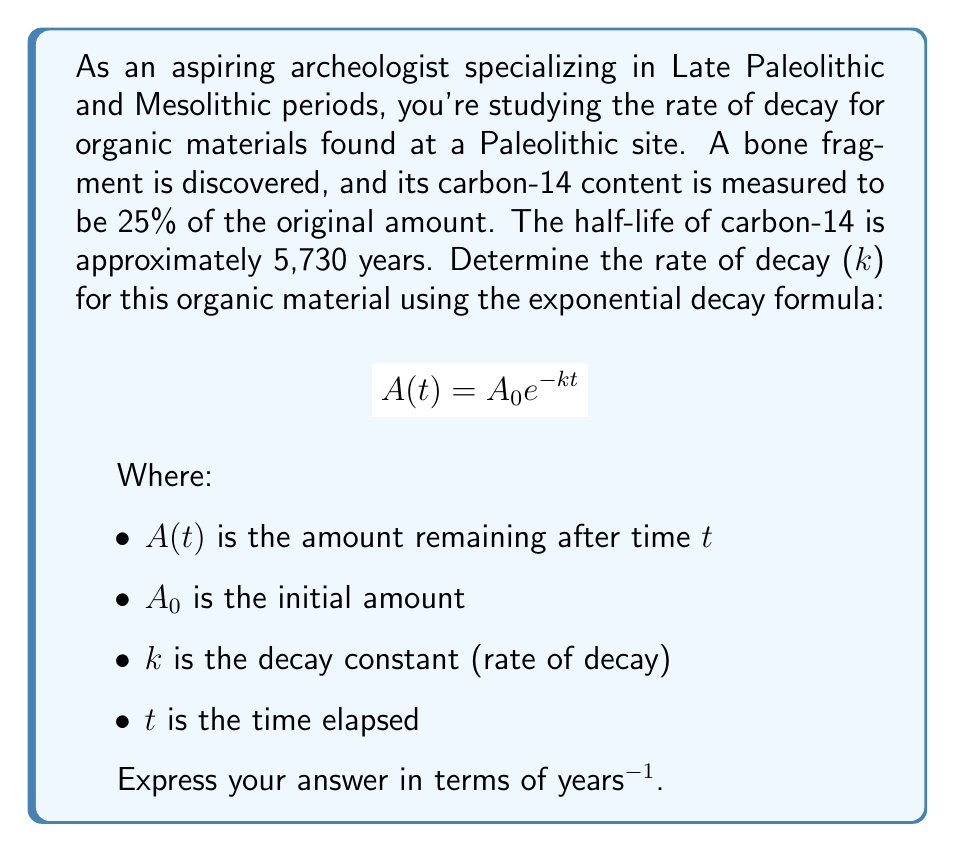Provide a solution to this math problem. Let's approach this step-by-step:

1) We know that 25% of the original amount remains, so:
   $A(t) = 0.25A_0$

2) We don't know the exact time $t$, but we can use the given information to solve for $k$.

3) Substituting into the exponential decay formula:
   $$0.25A_0 = A_0 e^{-kt}$$

4) Simplify by dividing both sides by $A_0$:
   $$0.25 = e^{-kt}$$

5) Take the natural logarithm of both sides:
   $$\ln(0.25) = -kt$$

6) Solve for $k$:
   $$k = -\frac{\ln(0.25)}{t}$$

7) We don't know $t$, but we can use the half-life information. After one half-life, 50% remains. So:
   $$0.5 = e^{-k(5730)}$$

8) Taking the natural logarithm and solving for $k$:
   $$k = -\frac{\ln(0.5)}{5730} \approx 0.000121$$

9) This is the decay constant $k$ in years^(-1).
Answer: $k \approx 0.000121$ years^(-1) 